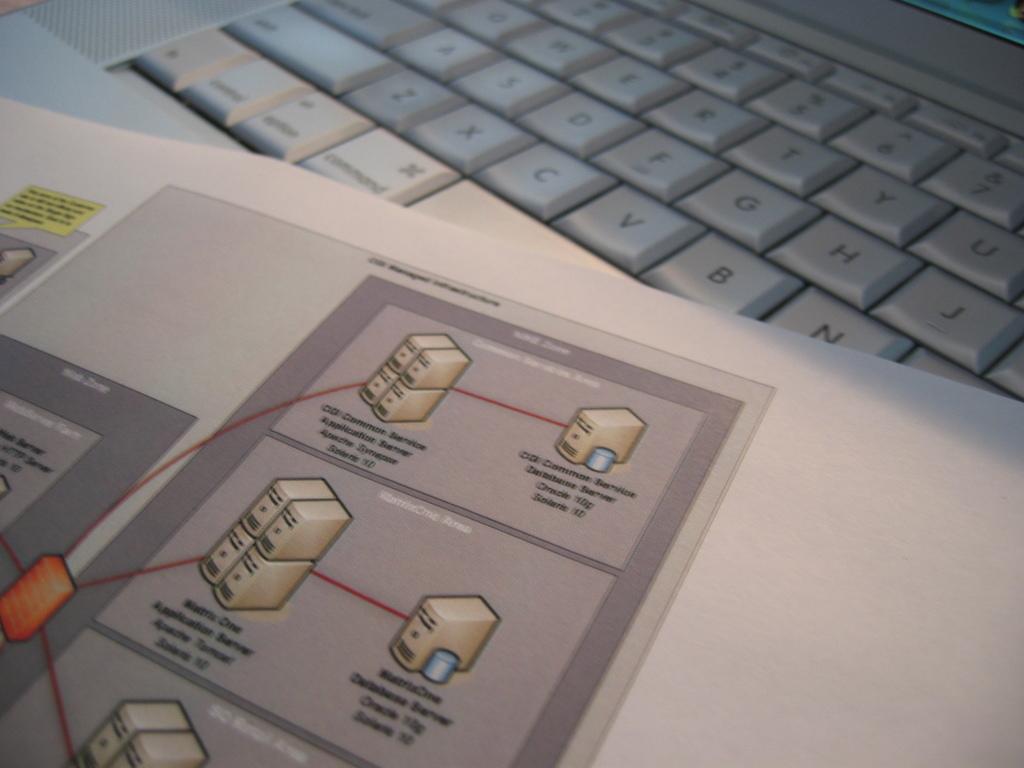In one or two sentences, can you explain what this image depicts? At the bottom of the picture, we see the white paper or a book in which we see the drawing. Beside that, we see the keyboard which is white in color. 